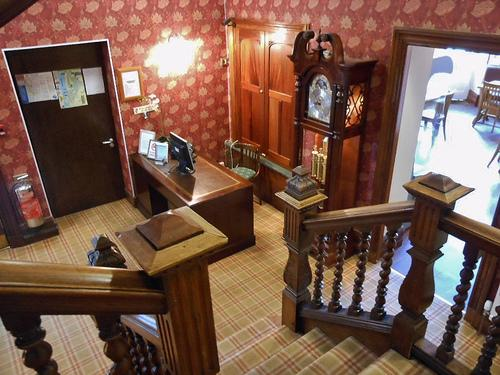Provide a brief description of the most prominent furniture in the image. A large wooden desk sits in a room with a desktop computer and a wooden chair featuring a green cushion. Describe the door and any attachments to the door within the image. A dark brown wooden door with a map, a silver handle, and paper notices can be observed in the image. Express the details of any lighting fixtures present in the indoor environment of the image. Indoor lighting for the receptionist can be seen, along with a bright light that is switched on above. Talk about any additional antique wooden elements you find in this image. An antique wooden stair rail, a wooden doorway to a closet, and wooden cupboards behind a chair are present. Describe the staircase and its features within the image. The staircase has plaid carpet steps, a wooden banister, and a twisted wooden bannister for support. What is the carpet like in the image? Describe its appearance and location. Brown and red plaid-covered carpet steps can be seen, as well as a carpeted stair case for customers. What time-telling device is present in the image? Describe its appearance. An antique wooden grandfather clock with decorative features and visible clock gears stands near the wall. Mention any safety equipment and security devices that can be seen in the image. A fire extinguisher for emergencies and a hotel security camera are present in the room. Can you spot any framed items in the image? Describe their placement and contents. There are paper notices on a wooden door, a picture frame on the wall, and framed papers on top of the desk. List any items found on a desk in the image and provide descriptions for them. A desktop computer monitor, an office workstation computer, and papers framed on the desktop can be seen. 